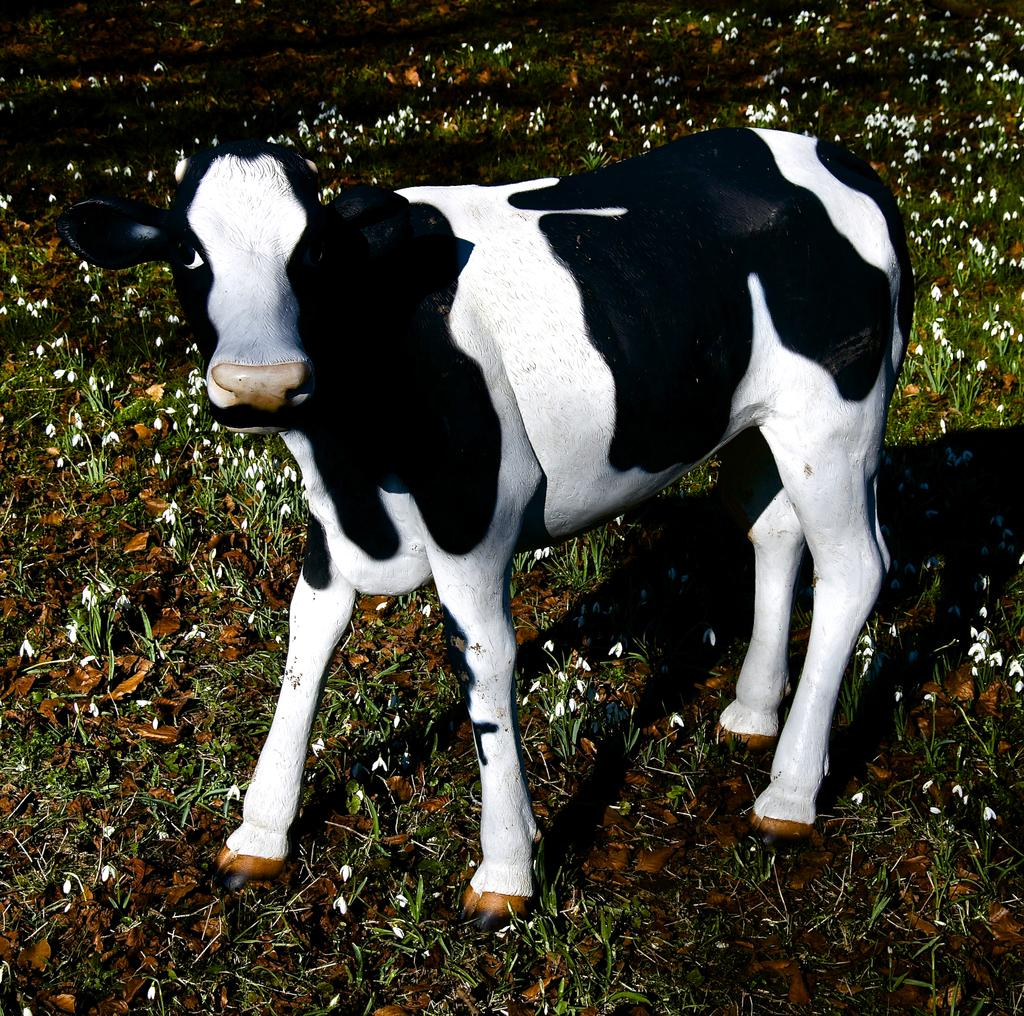What animal is present in the image? There is a cow in the image. What is the cow's position in the image? The cow is standing on the ground. What type of vegetation can be seen in the background of the image? There is grass visible in the background of the image. What type of quiver is the cow holding in the image? There is no quiver present in the image; the cow is simply standing on the ground. 